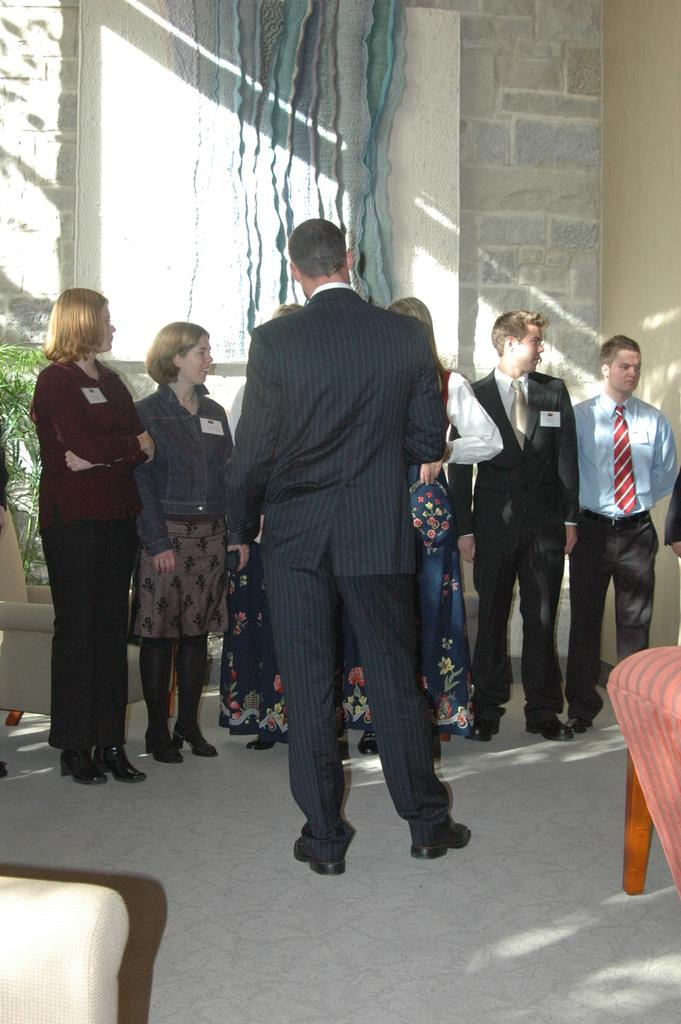How many people are in the image? There is a group of people in the image, but the exact number cannot be determined from the provided facts. Where are the people located in the image? The people are standing on the floor and sofas in the image. What can be seen in the background of the image? There is a wall, a window, and trees visible in the background of the image. What type of location might the image have been taken in? The image may have been taken in a hall, based on the presence of sofas and the arrangement of people. Can you see any worms crawling on the floor in the image? There is no mention of worms in the provided facts, and therefore, we cannot determine if any are present in the image. 